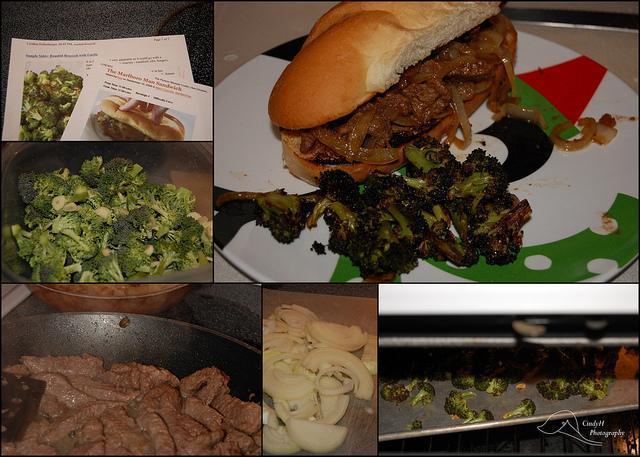How many bowls are visible?
Give a very brief answer. 1. How many sandwiches are in the photo?
Give a very brief answer. 2. How many broccolis are there?
Give a very brief answer. 3. 